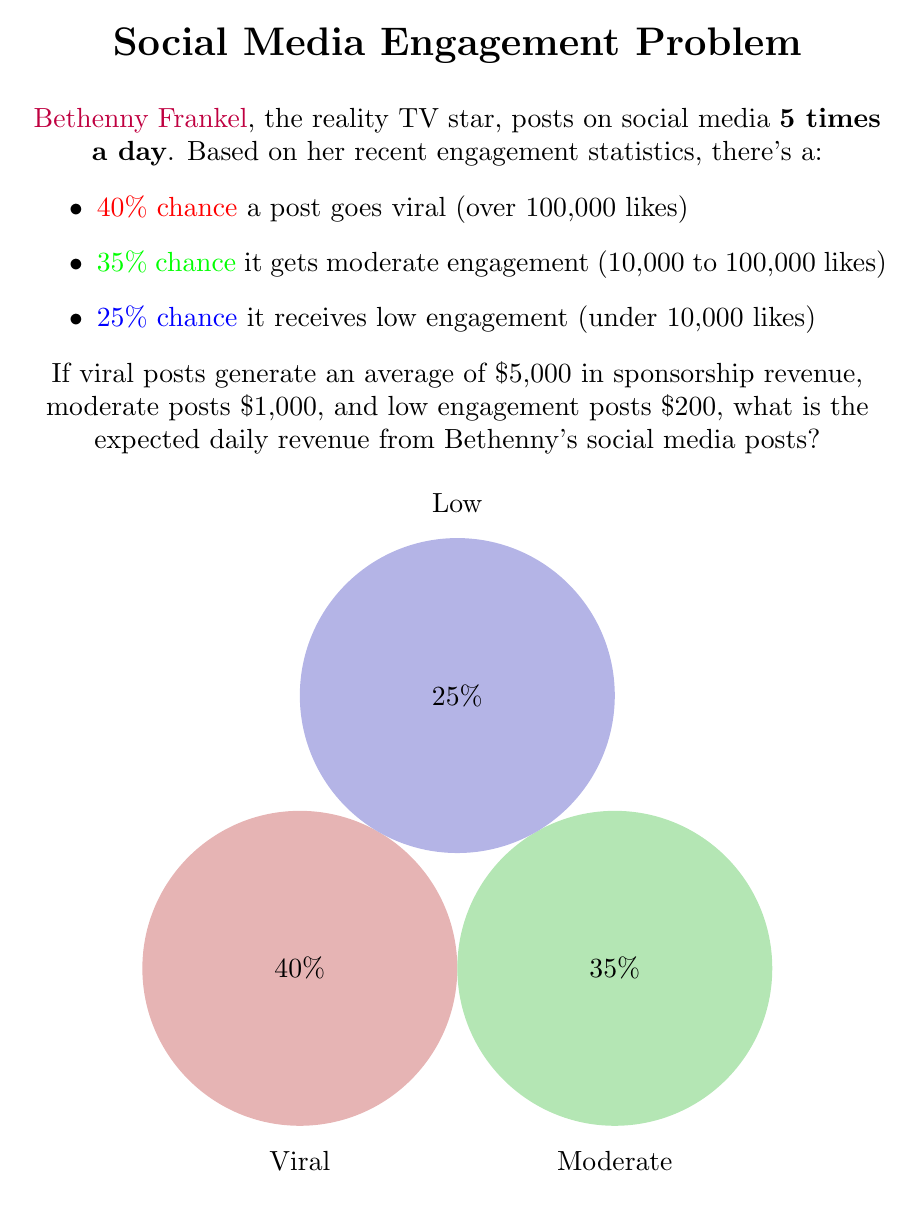Can you solve this math problem? Let's approach this step-by-step:

1) First, we need to calculate the expected revenue for a single post:

   a) Probability of viral post: 40% = 0.4
      Revenue from viral post: $5,000
      Expected revenue: $0.4 \times 5000 = $2000$

   b) Probability of moderate post: 35% = 0.35
      Revenue from moderate post: $1,000
      Expected revenue: $0.35 \times 1000 = $350$

   c) Probability of low engagement post: 25% = 0.25
      Revenue from low engagement post: $200
      Expected revenue: $0.25 \times 200 = $50$

2) The total expected revenue for a single post is the sum of these:

   $E(\text{revenue per post}) = 2000 + 350 + 50 = $2400$

3) Bethenny posts 5 times a day, so we multiply this by 5:

   $E(\text{daily revenue}) = 5 \times 2400 = $12000$

Therefore, the expected daily revenue from Bethenny's social media posts is $12,000.
Answer: $12,000 